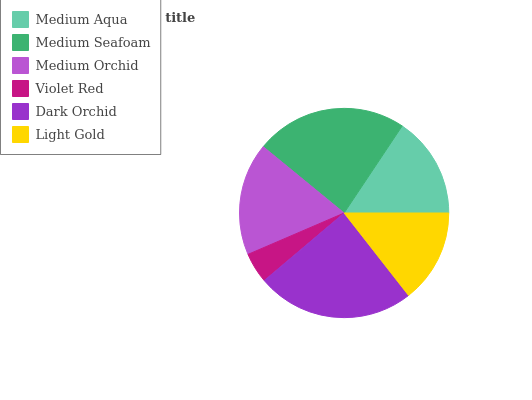Is Violet Red the minimum?
Answer yes or no. Yes. Is Dark Orchid the maximum?
Answer yes or no. Yes. Is Medium Seafoam the minimum?
Answer yes or no. No. Is Medium Seafoam the maximum?
Answer yes or no. No. Is Medium Seafoam greater than Medium Aqua?
Answer yes or no. Yes. Is Medium Aqua less than Medium Seafoam?
Answer yes or no. Yes. Is Medium Aqua greater than Medium Seafoam?
Answer yes or no. No. Is Medium Seafoam less than Medium Aqua?
Answer yes or no. No. Is Medium Orchid the high median?
Answer yes or no. Yes. Is Medium Aqua the low median?
Answer yes or no. Yes. Is Violet Red the high median?
Answer yes or no. No. Is Medium Orchid the low median?
Answer yes or no. No. 